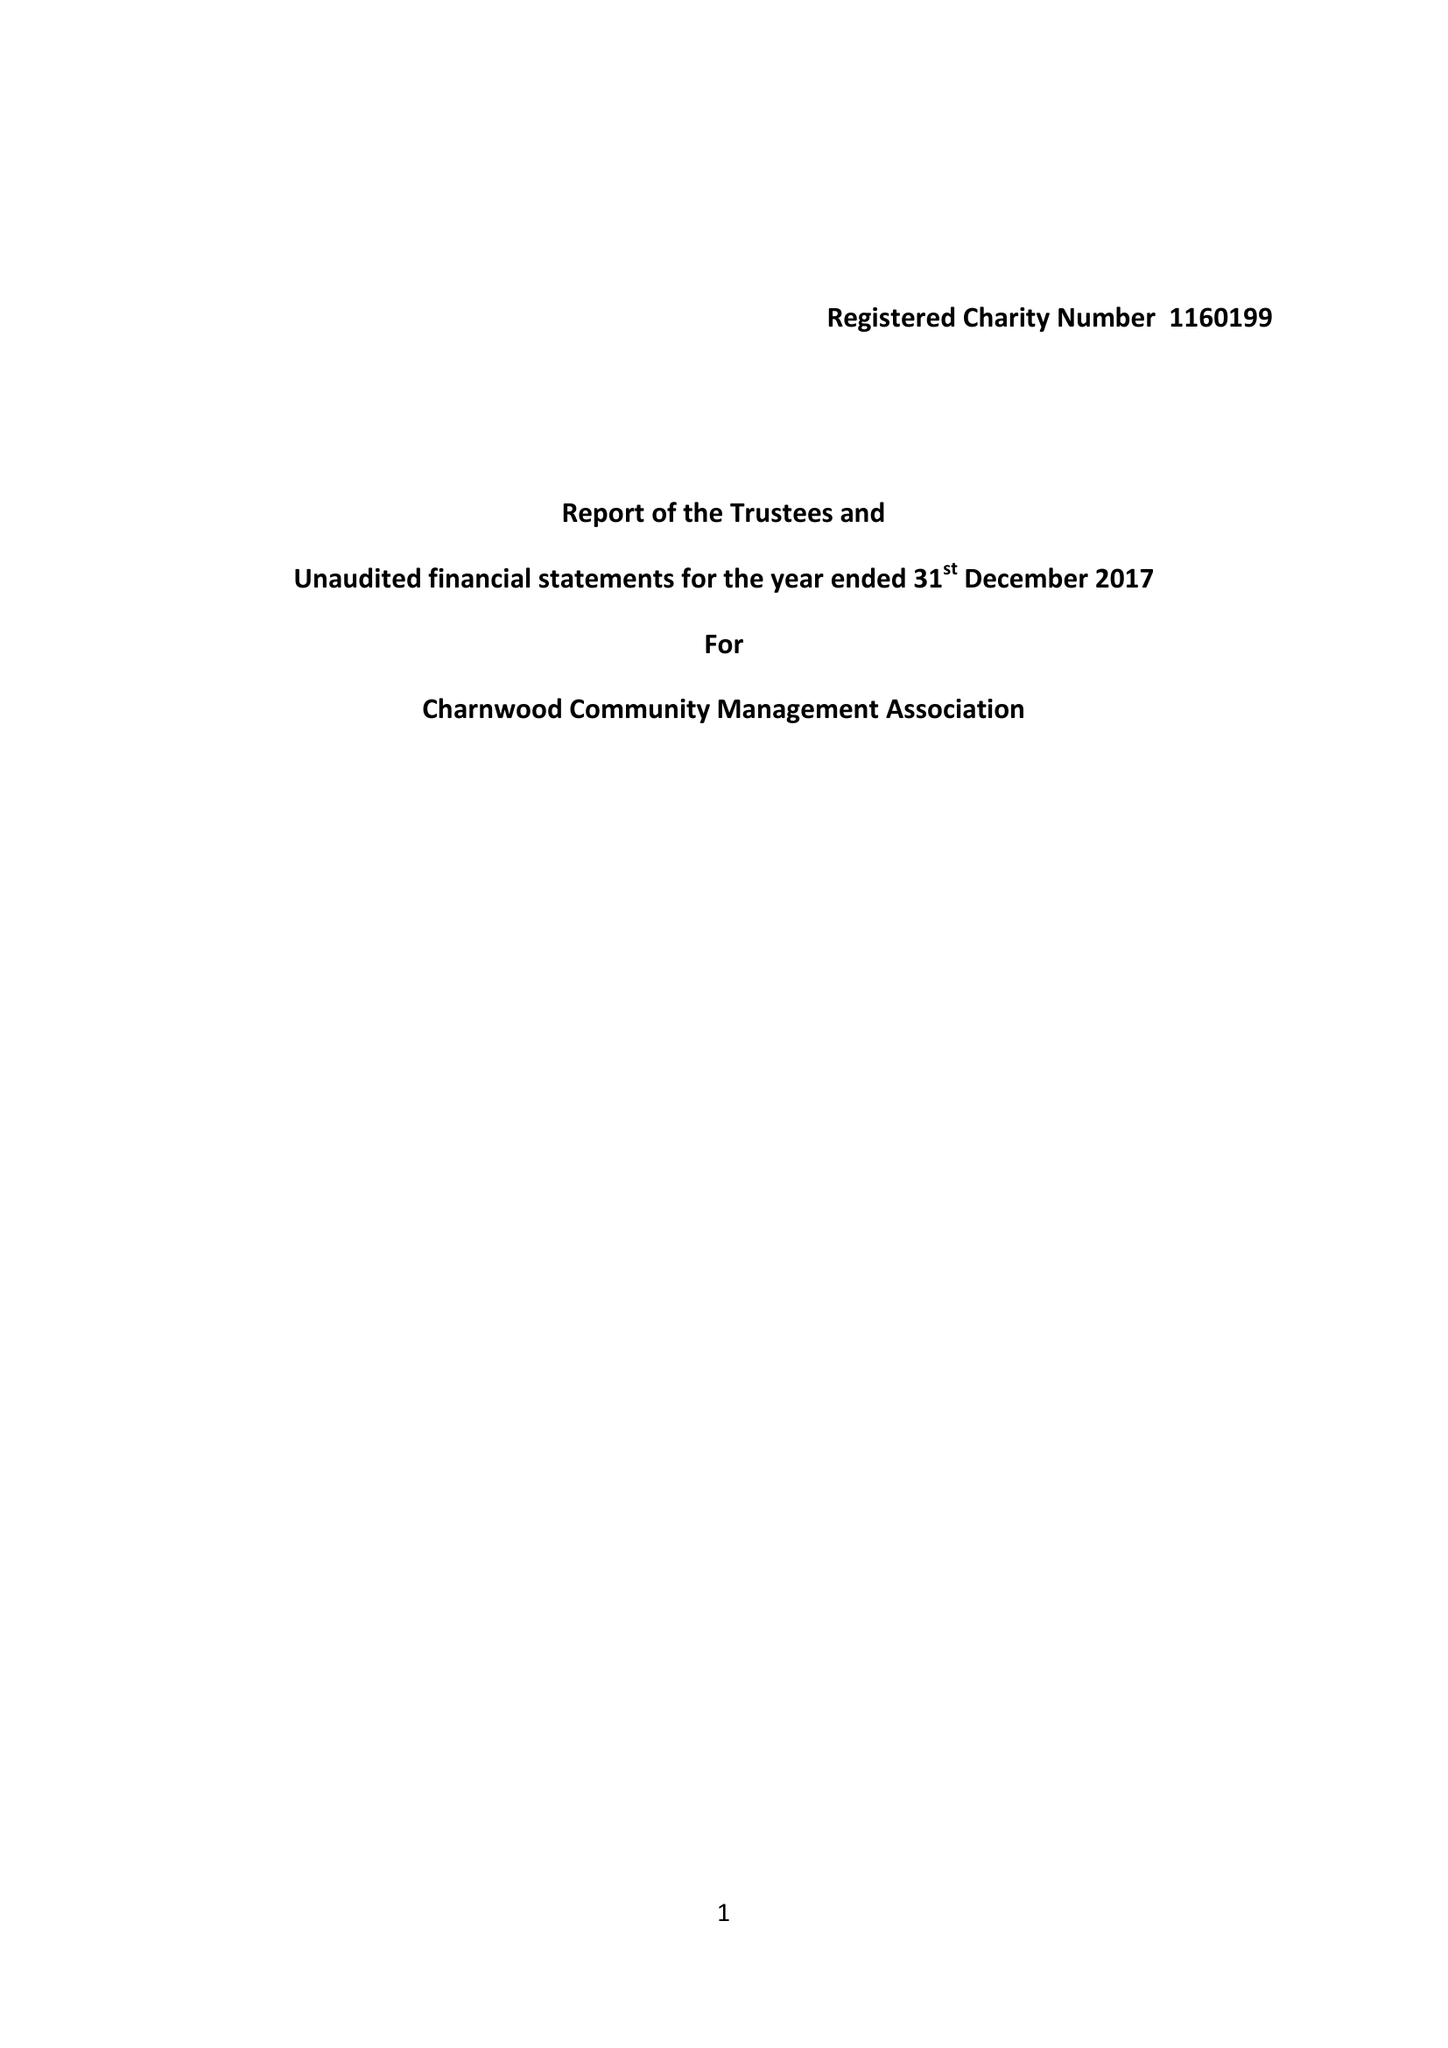What is the value for the spending_annually_in_british_pounds?
Answer the question using a single word or phrase. 15.00 